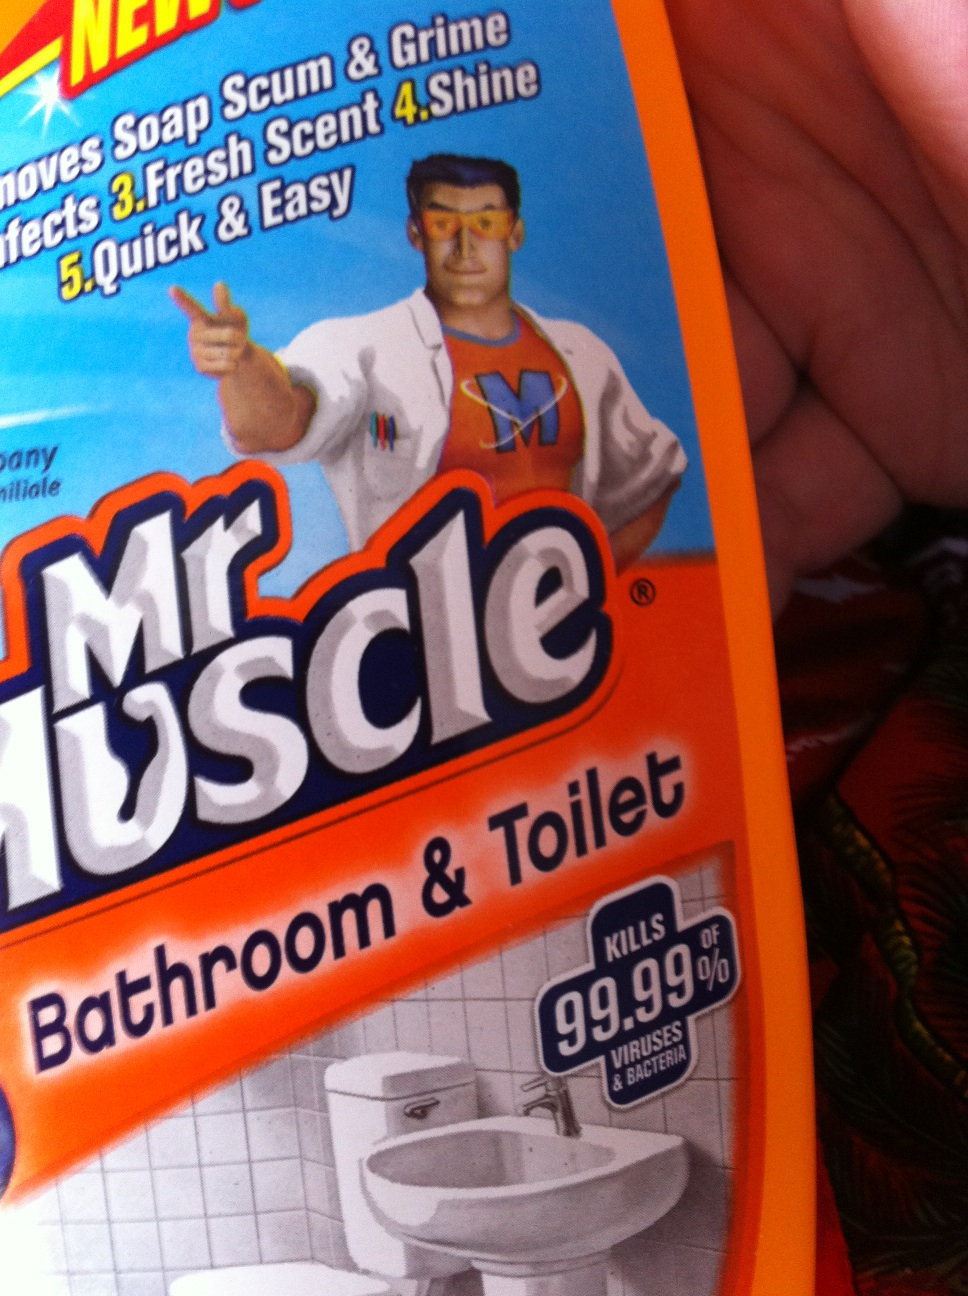Does this product have any safety warnings I should be aware of? Yes, safety is important when using cleaning products. 'Mr. Muscle Bathroom & Toilet' cleaner should be kept out of reach of children and pets. Avoid contact with eyes, skin and clothing, and do not ingest the product. Use it in well-ventilated areas to prevent inhalation of any fumes. In the case of accidental contact or ingestion, follow the emergency instructions provided on the bottle label. 